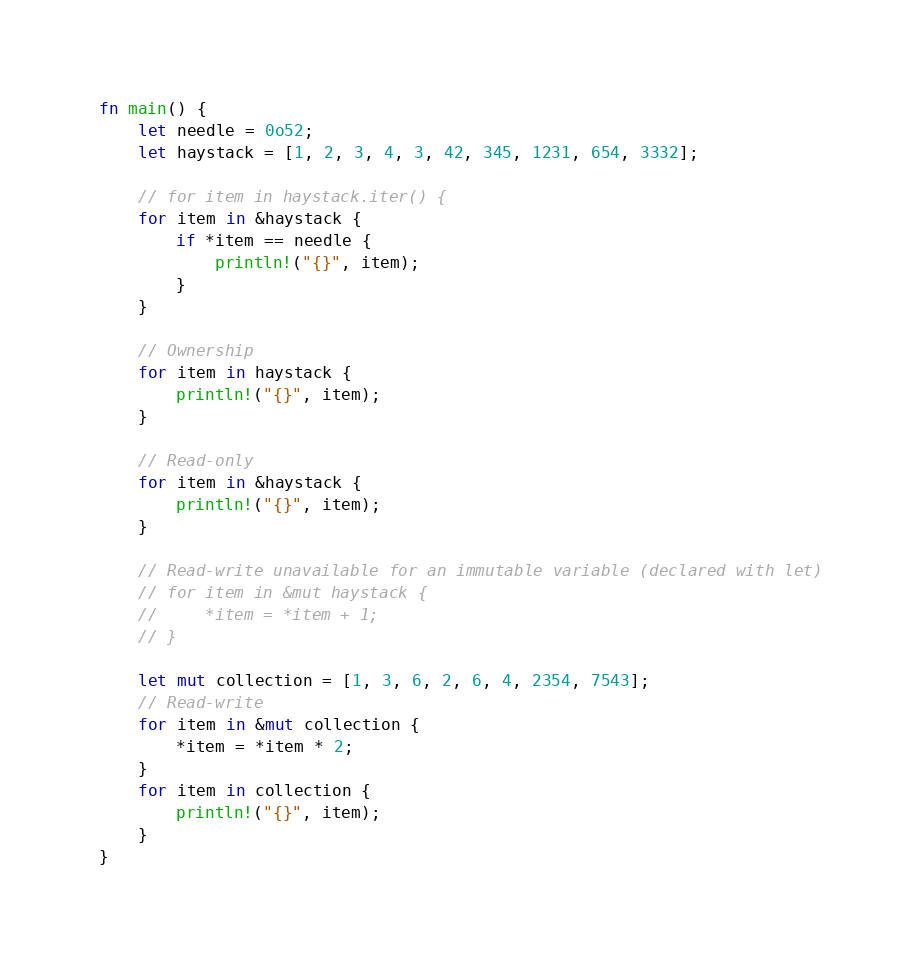Convert code to text. <code><loc_0><loc_0><loc_500><loc_500><_Rust_>fn main() {
    let needle = 0o52;
    let haystack = [1, 2, 3, 4, 3, 42, 345, 1231, 654, 3332];
    
    // for item in haystack.iter() {
    for item in &haystack {
        if *item == needle {
            println!("{}", item);
        }
    }

    // Ownership
    for item in haystack {
        println!("{}", item);
    }

    // Read-only
    for item in &haystack {
        println!("{}", item);
    }

    // Read-write unavailable for an immutable variable (declared with let)
    // for item in &mut haystack {
    //     *item = *item + 1;
    // }

    let mut collection = [1, 3, 6, 2, 6, 4, 2354, 7543];
    // Read-write
    for item in &mut collection {
        *item = *item * 2;
    }
    for item in collection {
        println!("{}", item);
    }
}</code> 